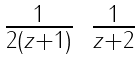Convert formula to latex. <formula><loc_0><loc_0><loc_500><loc_500>\begin{matrix} \frac { 1 } { 2 ( z + 1 ) } & \frac { 1 } { z + 2 } \end{matrix}</formula> 